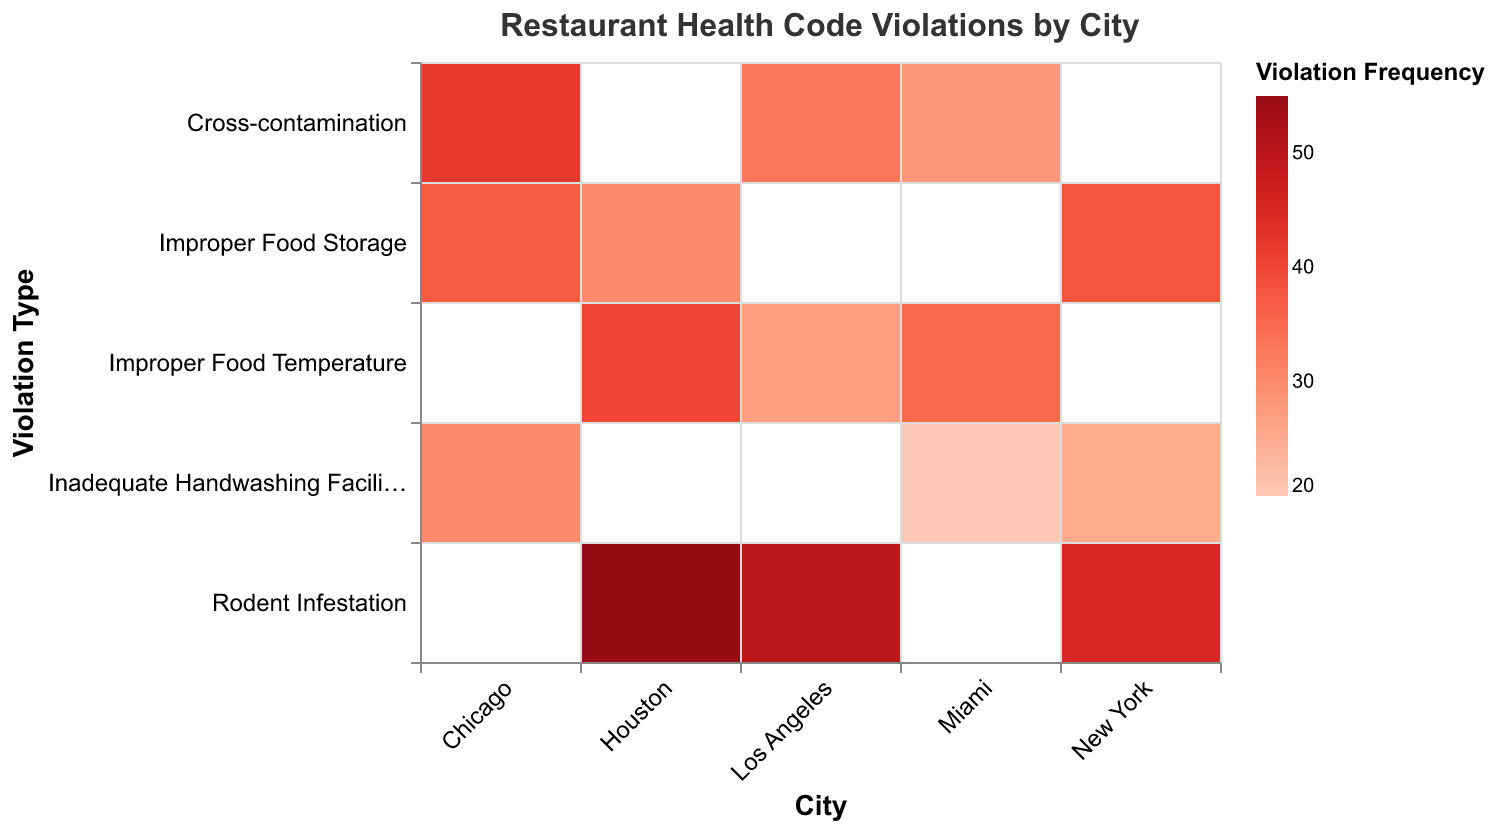What is the title of the heatmap? The title of the heatmap is prominently displayed at the top of the figure in bold font.
Answer: Restaurant Health Code Violations by City Which city has the highest frequency of rodent infestation violations? You need to look for the darkest shade in the row corresponding to "Rodent Infestation." In this case, Houston has the highest frequency with the darkest shade.
Answer: Houston What is the frequency of improper food temperature violations in Los Angeles? Find the row labeled "Improper Food Temperature" and move across to the column labeled "Los Angeles." The value in that cell is 27.
Answer: 27 How many total violations for improper food storage are there across all cities? Add up the frequencies in the "Improper Food Storage" row: 38 (New York) + 37 (Chicago) + 30 (Houston) = 105.
Answer: 105 Which violation type in Miami has the lowest frequency, and what is that frequency? Identify the lightest shade within the "Miami" column. "Inadequate Handwashing Facilities" is the lightest shade with a frequency of 20.
Answer: Inadequate Handwashing Facilities, 20 Compare the frequency of cross-contamination violations between Los Angeles and Chicago. Which city has a higher frequency and by how much? Look at the "Cross-contamination" row and compare the values for Los Angeles (33) and Chicago (42). Chicago has a higher frequency: 42 - 33 = 9.
Answer: Chicago, by 9 What is the average frequency of violations for New York? Sum the frequencies in the "New York" column: 45 + 38 + 25 = 108. Divide by the number of violation types (3): 108 / 3 = 36.
Answer: 36 Which city has the highest overall number of violations, and what is that number? Sum the frequencies in each city's column and compare. New York: 45 + 38 + 25 = 108, Los Angeles: 33 + 27 + 50 = 110, Chicago: 30 + 42 + 37 = 109, Houston: 55 + 40 + 30 = 125, Miami: 20 + 35 + 28 = 83. Houston has the highest total of 125.
Answer: Houston, 125 How does the frequency of inadequate handwashing facilities violations in Chicago compare to that in Miami? Look at the "Inadequate Handwashing Facilities" row and compare the values for Chicago (30) and Miami (20). Chicago has a higher frequency by 10.
Answer: Chicago, by 10 